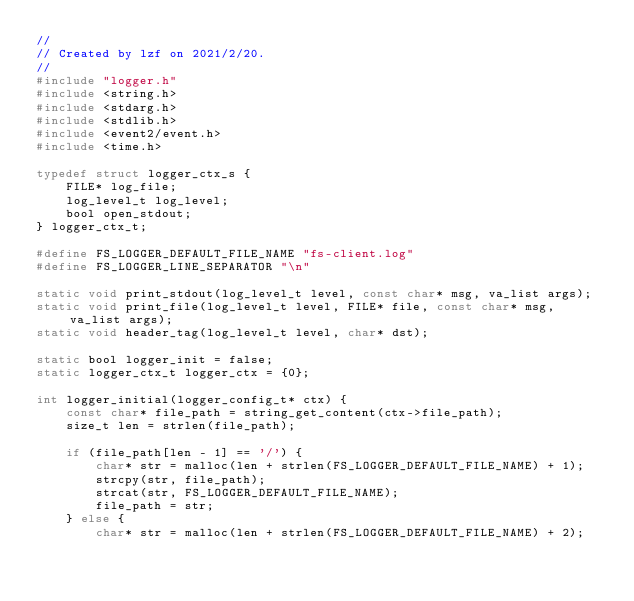Convert code to text. <code><loc_0><loc_0><loc_500><loc_500><_C_>//
// Created by lzf on 2021/2/20.
//
#include "logger.h"
#include <string.h>
#include <stdarg.h>
#include <stdlib.h>
#include <event2/event.h>
#include <time.h>

typedef struct logger_ctx_s {
    FILE* log_file;
    log_level_t log_level;
    bool open_stdout;
} logger_ctx_t;

#define FS_LOGGER_DEFAULT_FILE_NAME "fs-client.log"
#define FS_LOGGER_LINE_SEPARATOR "\n"

static void print_stdout(log_level_t level, const char* msg, va_list args);
static void print_file(log_level_t level, FILE* file, const char* msg, va_list args);
static void header_tag(log_level_t level, char* dst);

static bool logger_init = false;
static logger_ctx_t logger_ctx = {0};

int logger_initial(logger_config_t* ctx) {
    const char* file_path = string_get_content(ctx->file_path);
    size_t len = strlen(file_path);

    if (file_path[len - 1] == '/') {
        char* str = malloc(len + strlen(FS_LOGGER_DEFAULT_FILE_NAME) + 1);
        strcpy(str, file_path);
        strcat(str, FS_LOGGER_DEFAULT_FILE_NAME);
        file_path = str;
    } else {
        char* str = malloc(len + strlen(FS_LOGGER_DEFAULT_FILE_NAME) + 2);</code> 